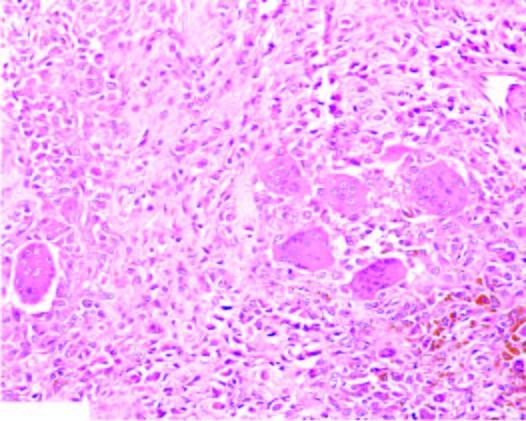what does the tumour show?
Answer the question using a single word or phrase. Infiltrate of small oval to spindled histiocytes with numerous interspersed multinucleate giant cells lyning in a background of fibrous tissue 